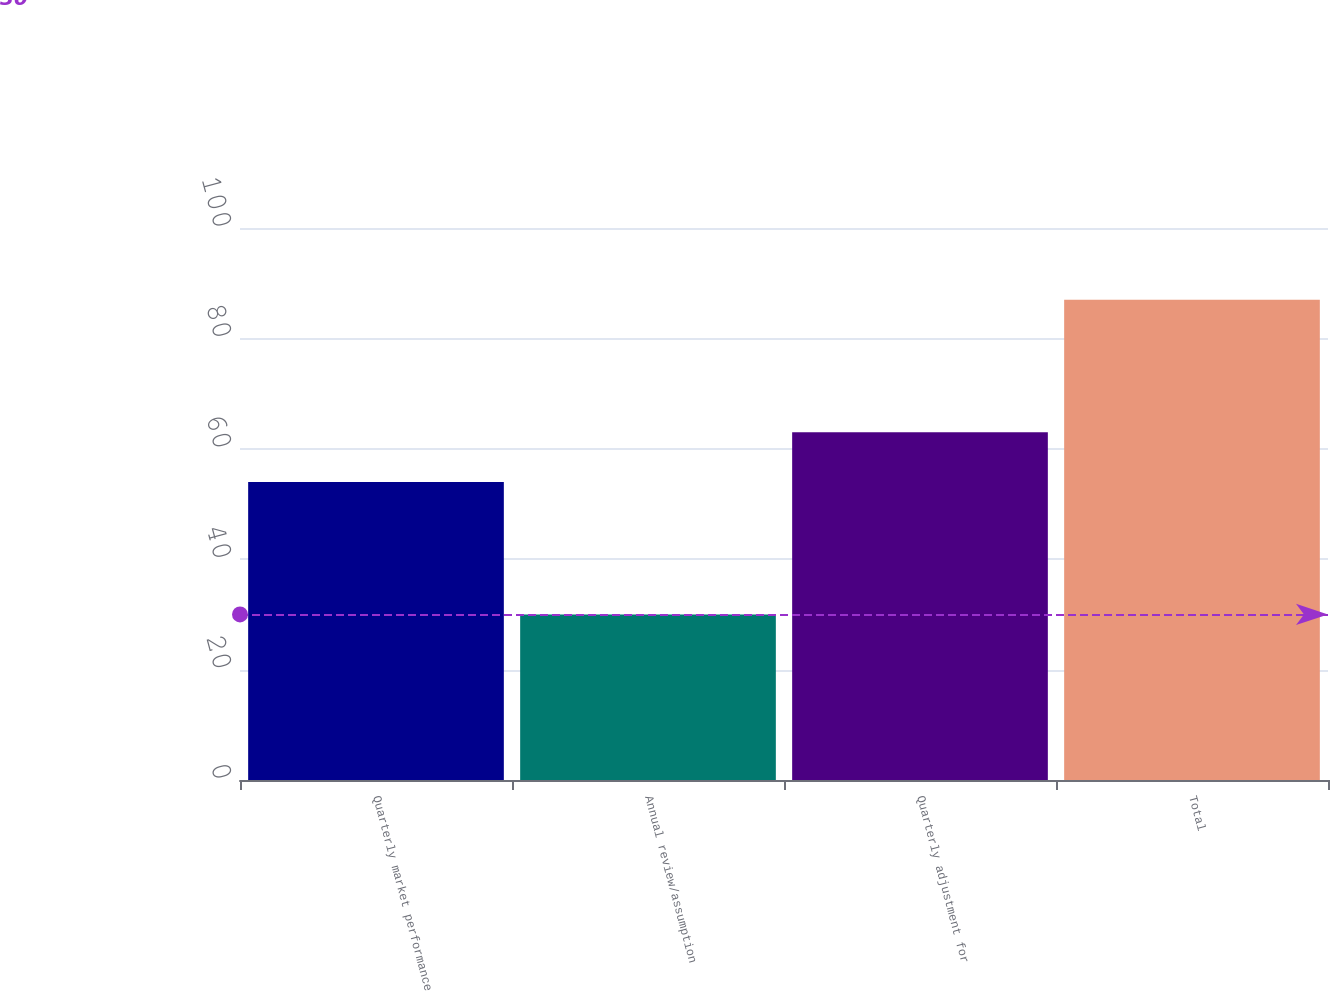Convert chart. <chart><loc_0><loc_0><loc_500><loc_500><bar_chart><fcel>Quarterly market performance<fcel>Annual review/assumption<fcel>Quarterly adjustment for<fcel>Total<nl><fcel>54<fcel>30<fcel>63<fcel>87<nl></chart> 